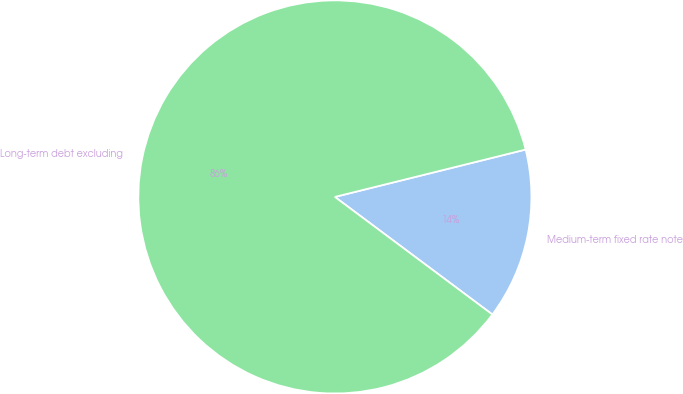Convert chart. <chart><loc_0><loc_0><loc_500><loc_500><pie_chart><fcel>Medium-term fixed rate note<fcel>Long-term debt excluding<nl><fcel>14.08%<fcel>85.92%<nl></chart> 